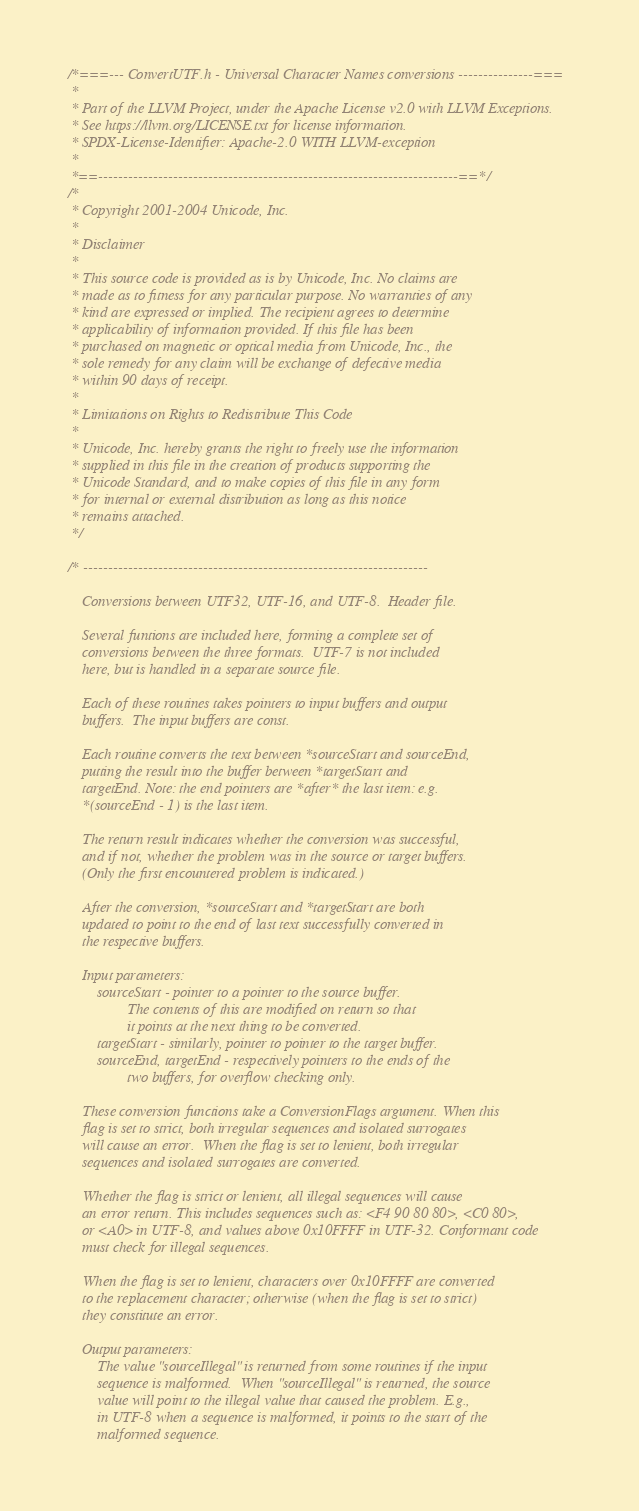<code> <loc_0><loc_0><loc_500><loc_500><_C_>/*===--- ConvertUTF.h - Universal Character Names conversions ---------------===
 *
 * Part of the LLVM Project, under the Apache License v2.0 with LLVM Exceptions.
 * See https://llvm.org/LICENSE.txt for license information.
 * SPDX-License-Identifier: Apache-2.0 WITH LLVM-exception
 *
 *==------------------------------------------------------------------------==*/
/*
 * Copyright 2001-2004 Unicode, Inc.
 *
 * Disclaimer
 *
 * This source code is provided as is by Unicode, Inc. No claims are
 * made as to fitness for any particular purpose. No warranties of any
 * kind are expressed or implied. The recipient agrees to determine
 * applicability of information provided. If this file has been
 * purchased on magnetic or optical media from Unicode, Inc., the
 * sole remedy for any claim will be exchange of defective media
 * within 90 days of receipt.
 *
 * Limitations on Rights to Redistribute This Code
 *
 * Unicode, Inc. hereby grants the right to freely use the information
 * supplied in this file in the creation of products supporting the
 * Unicode Standard, and to make copies of this file in any form
 * for internal or external distribution as long as this notice
 * remains attached.
 */

/* ---------------------------------------------------------------------

    Conversions between UTF32, UTF-16, and UTF-8.  Header file.

    Several funtions are included here, forming a complete set of
    conversions between the three formats.  UTF-7 is not included
    here, but is handled in a separate source file.

    Each of these routines takes pointers to input buffers and output
    buffers.  The input buffers are const.

    Each routine converts the text between *sourceStart and sourceEnd,
    putting the result into the buffer between *targetStart and
    targetEnd. Note: the end pointers are *after* the last item: e.g.
    *(sourceEnd - 1) is the last item.

    The return result indicates whether the conversion was successful,
    and if not, whether the problem was in the source or target buffers.
    (Only the first encountered problem is indicated.)

    After the conversion, *sourceStart and *targetStart are both
    updated to point to the end of last text successfully converted in
    the respective buffers.

    Input parameters:
        sourceStart - pointer to a pointer to the source buffer.
                The contents of this are modified on return so that
                it points at the next thing to be converted.
        targetStart - similarly, pointer to pointer to the target buffer.
        sourceEnd, targetEnd - respectively pointers to the ends of the
                two buffers, for overflow checking only.

    These conversion functions take a ConversionFlags argument. When this
    flag is set to strict, both irregular sequences and isolated surrogates
    will cause an error.  When the flag is set to lenient, both irregular
    sequences and isolated surrogates are converted.

    Whether the flag is strict or lenient, all illegal sequences will cause
    an error return. This includes sequences such as: <F4 90 80 80>, <C0 80>,
    or <A0> in UTF-8, and values above 0x10FFFF in UTF-32. Conformant code
    must check for illegal sequences.

    When the flag is set to lenient, characters over 0x10FFFF are converted
    to the replacement character; otherwise (when the flag is set to strict)
    they constitute an error.

    Output parameters:
        The value "sourceIllegal" is returned from some routines if the input
        sequence is malformed.  When "sourceIllegal" is returned, the source
        value will point to the illegal value that caused the problem. E.g.,
        in UTF-8 when a sequence is malformed, it points to the start of the
        malformed sequence.
</code> 